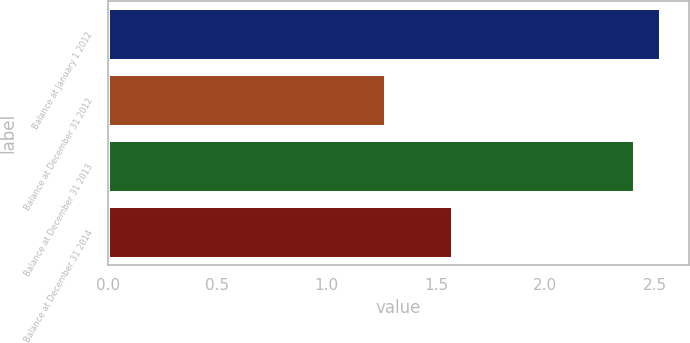<chart> <loc_0><loc_0><loc_500><loc_500><bar_chart><fcel>Balance at January 1 2012<fcel>Balance at December 31 2012<fcel>Balance at December 31 2013<fcel>Balance at December 31 2014<nl><fcel>2.53<fcel>1.27<fcel>2.41<fcel>1.58<nl></chart> 